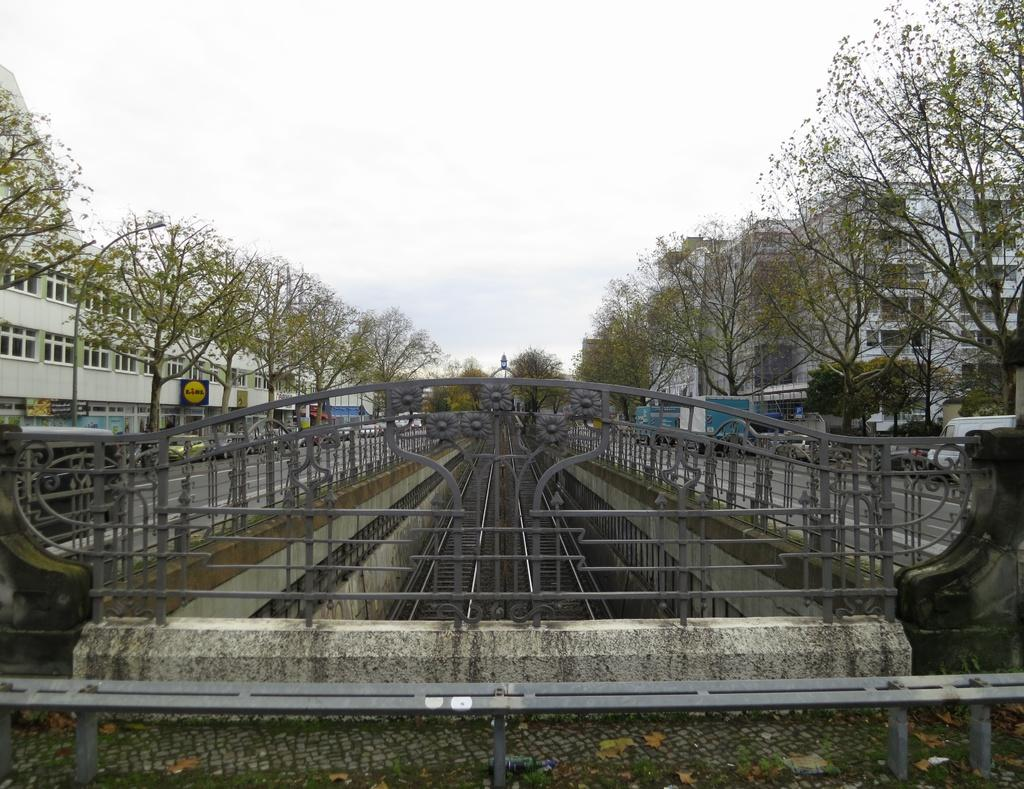What structures are located at the bottom of the image? There is a fence and wall at the bottom of the image. What can be seen on both sides of the image? There are buildings on the right side and left side of the image. What type of vegetation is present in the image? There are trees in the image. What type of transportation is visible in the image? There are vehicles in the image. What is visible at the top of the image? The sky is visible at the top of the image. Is there a letter addressed to the market in the image? There is no mention of a letter or a market in the image. The image primarily features a fence, wall, buildings, trees, vehicles, and the sky. 